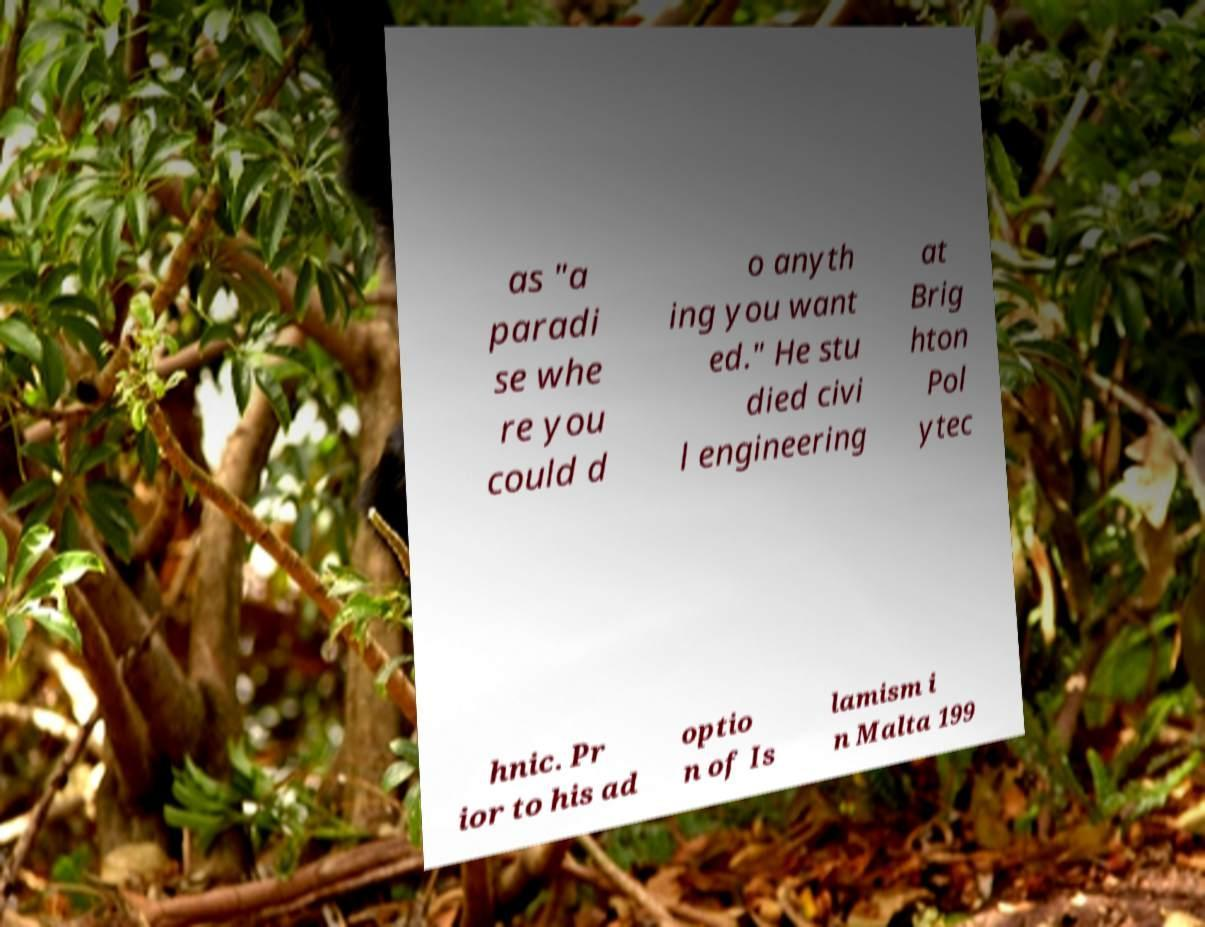Could you assist in decoding the text presented in this image and type it out clearly? as "a paradi se whe re you could d o anyth ing you want ed." He stu died civi l engineering at Brig hton Pol ytec hnic. Pr ior to his ad optio n of Is lamism i n Malta 199 